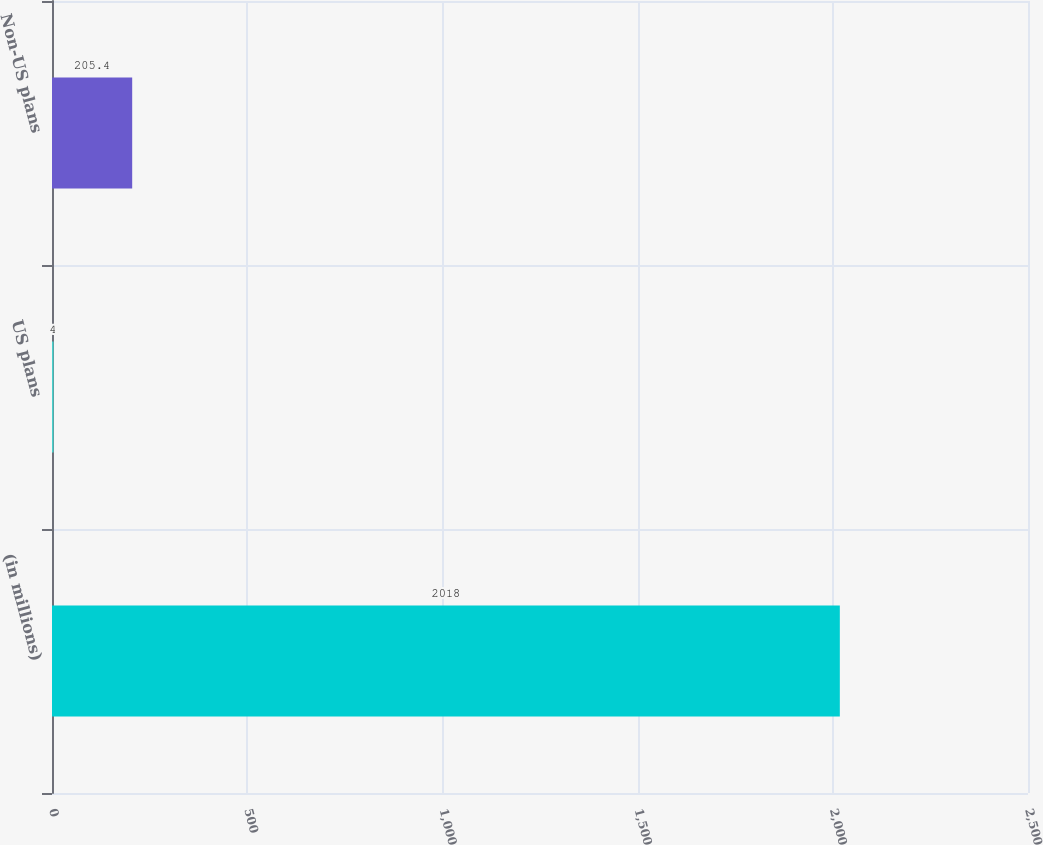<chart> <loc_0><loc_0><loc_500><loc_500><bar_chart><fcel>(in millions)<fcel>US plans<fcel>Non-US plans<nl><fcel>2018<fcel>4<fcel>205.4<nl></chart> 